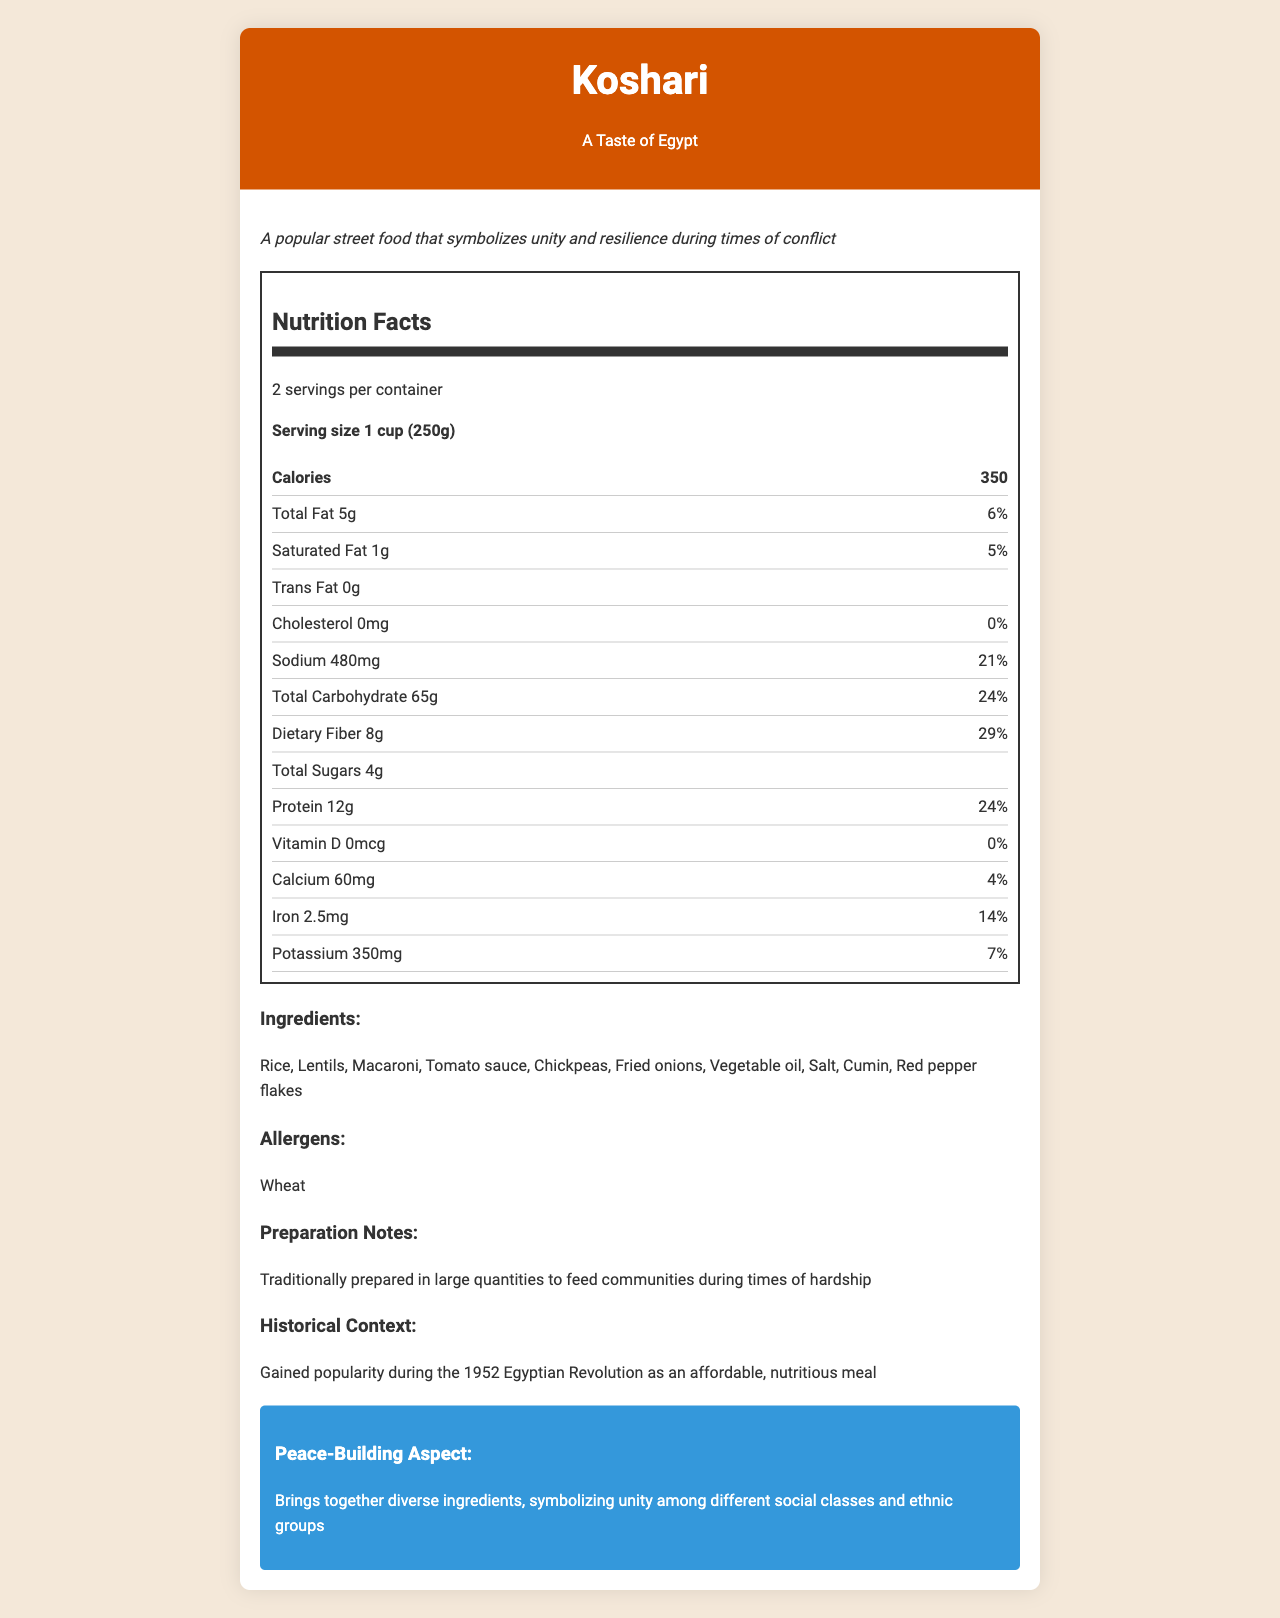what is the serving size? The serving size is listed in the nutrition facts section as 1 cup (250g).
Answer: Serving size is 1 cup (250g) what is the daily value percentage of iron? The daily value percentage of iron is listed in the nutrition facts section as 14%.
Answer: 14% what ingredients are in Koshari? The list of ingredients is provided in the ingredients section.
Answer: Rice, Lentils, Macaroni, Tomato sauce, Chickpeas, Fried onions, Vegetable oil, Salt, Cumin, Red pepper flakes how many calories are in one serving? The calories per serving is listed in the nutrition facts section as 350 calories.
Answer: 350 calories What is the amount of dietary fiber per serving? The amount is listed under dietary fiber in the nutrition facts section.
Answer: 8g How much sodium is in each serving of Koshari? A. 300mg B. 480mg C. 640mg The sodium content is listed as 480mg in the nutrition facts section.
Answer: B. 480mg Which of the following nutrients has the highest daily value percentage per serving of Koshari? A. Sodium B. Carbohydrate C. Dietary Fiber Dietary fiber has a daily value percentage of 29%, which is higher than both sodium (21%) and carbohydrate (24%).
Answer: C. Dietary Fiber Does Koshari contain cholesterol? The nutrition facts section shows that the cholesterol content is 0mg.
Answer: No Summarize the main idea of the document. The document combines nutritional data, cultural significance, historical context, and peace-building aspects of Koshari to give a comprehensive view of the dish.
Answer: The document provides nutrition facts for Koshari, a culturally significant dish from Egypt known for its unity and resilience symbolism. The document includes details like ingredients, nutritional values, allergens, preparation notes, historical context, and its peace-building aspect. How many servings are there per container? The servings per container are listed in the nutrition facts section as 2.
Answer: 2 servings per container Can you get detailed instructions on how to cook Koshari from this document? The document does not provide detailed cooking instructions, only general preparation notes.
Answer: Cannot be determined what symbol of unity and resilience does Koshari represent during times of conflict? This is mentioned in the cultural significance section of the document.
Answer: Koshari symbolizes unity and resilience. Is there any allergen information provided? The allergen information is provided, stating that Koshari contains wheat.
Answer: Yes 